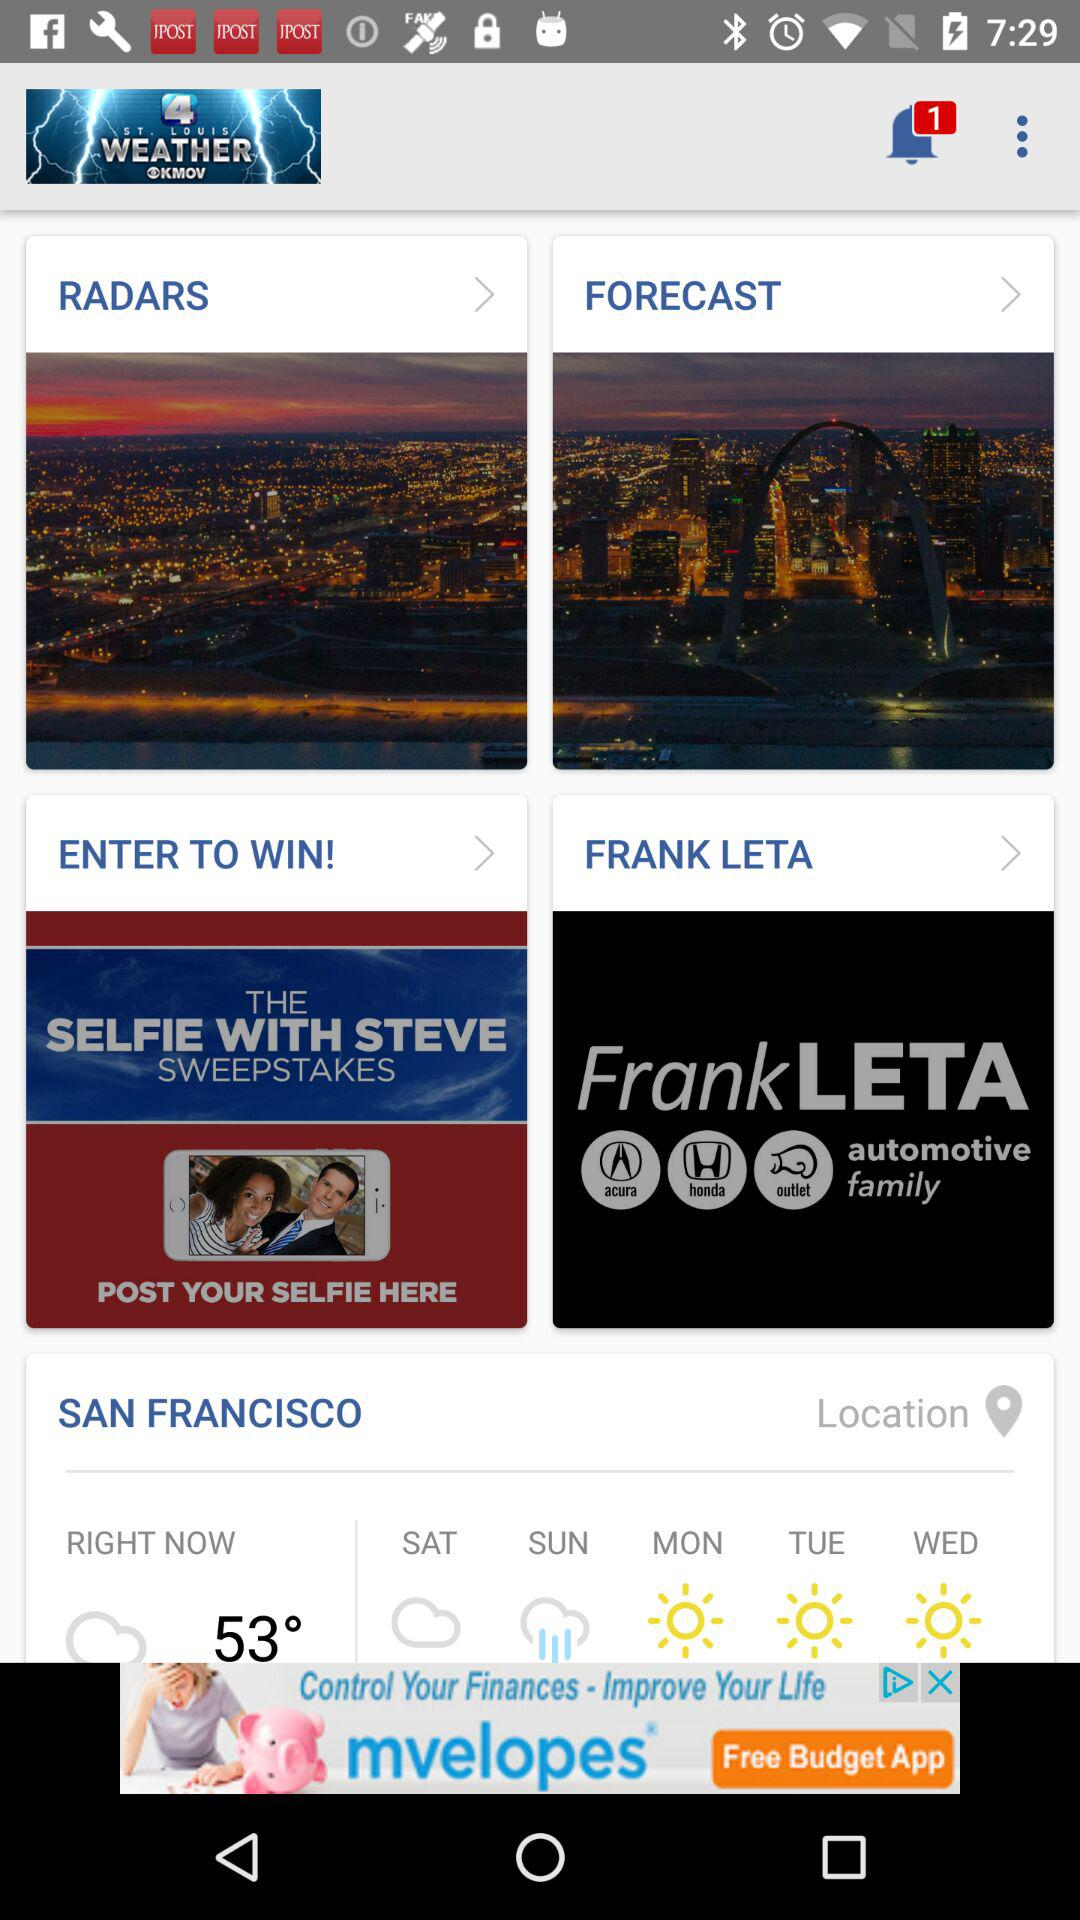How's the weather on Monday? The weather on Monday is sunny. 